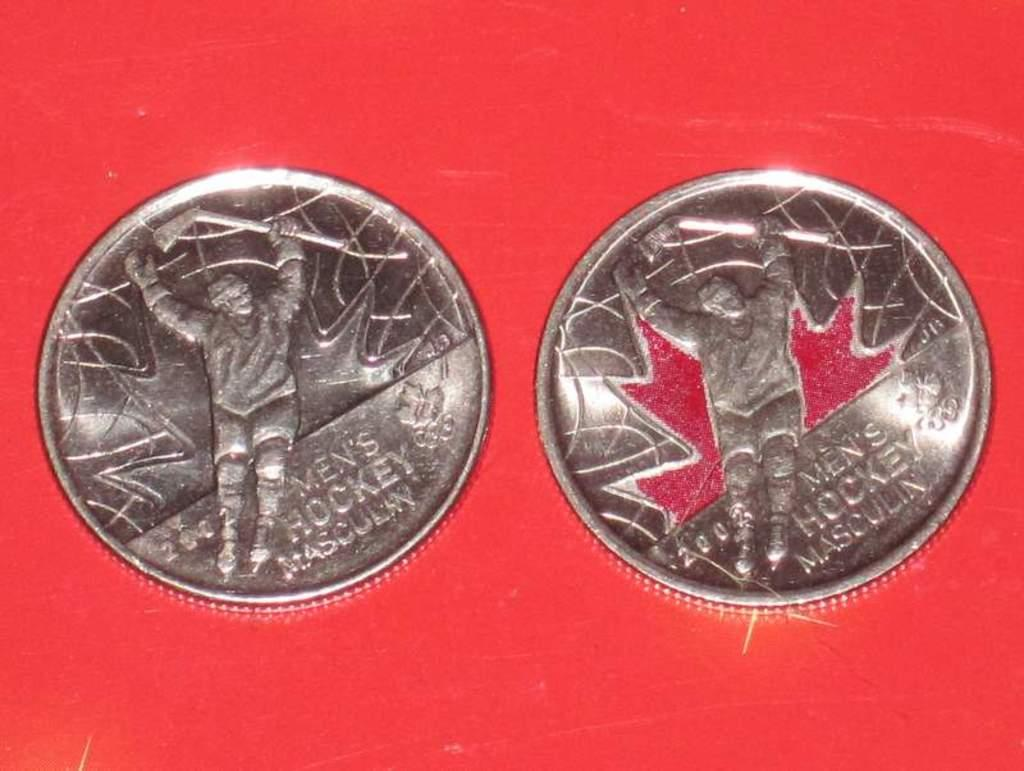<image>
Describe the image concisely. Two  coins with  the inscription Men's hockey on them 